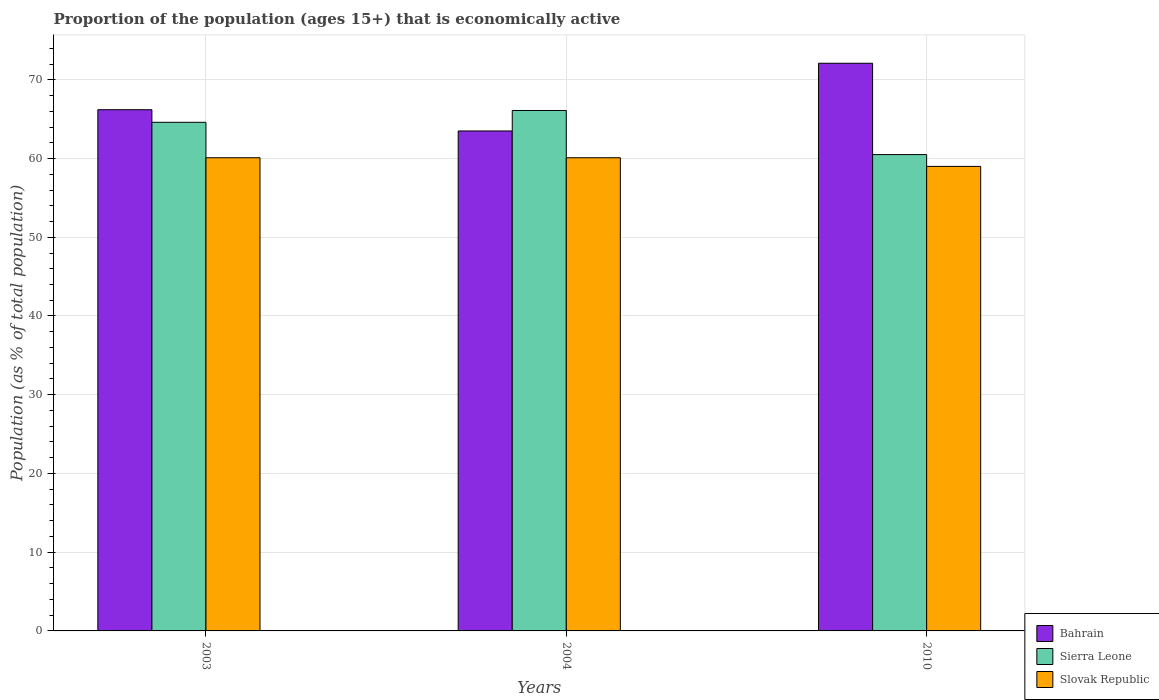How many different coloured bars are there?
Make the answer very short. 3. How many groups of bars are there?
Provide a succinct answer. 3. How many bars are there on the 3rd tick from the left?
Offer a terse response. 3. What is the proportion of the population that is economically active in Sierra Leone in 2004?
Your response must be concise. 66.1. Across all years, what is the maximum proportion of the population that is economically active in Sierra Leone?
Your answer should be very brief. 66.1. Across all years, what is the minimum proportion of the population that is economically active in Bahrain?
Provide a succinct answer. 63.5. In which year was the proportion of the population that is economically active in Bahrain minimum?
Offer a terse response. 2004. What is the total proportion of the population that is economically active in Slovak Republic in the graph?
Ensure brevity in your answer.  179.2. What is the difference between the proportion of the population that is economically active in Bahrain in 2003 and that in 2010?
Offer a very short reply. -5.9. What is the difference between the proportion of the population that is economically active in Bahrain in 2003 and the proportion of the population that is economically active in Sierra Leone in 2004?
Provide a short and direct response. 0.1. What is the average proportion of the population that is economically active in Sierra Leone per year?
Offer a very short reply. 63.73. In the year 2004, what is the difference between the proportion of the population that is economically active in Bahrain and proportion of the population that is economically active in Slovak Republic?
Provide a short and direct response. 3.4. In how many years, is the proportion of the population that is economically active in Sierra Leone greater than 2 %?
Your response must be concise. 3. What is the ratio of the proportion of the population that is economically active in Bahrain in 2003 to that in 2004?
Your answer should be very brief. 1.04. Is the proportion of the population that is economically active in Bahrain in 2003 less than that in 2004?
Make the answer very short. No. Is the difference between the proportion of the population that is economically active in Bahrain in 2003 and 2004 greater than the difference between the proportion of the population that is economically active in Slovak Republic in 2003 and 2004?
Your answer should be very brief. Yes. What is the difference between the highest and the lowest proportion of the population that is economically active in Sierra Leone?
Ensure brevity in your answer.  5.6. Is the sum of the proportion of the population that is economically active in Sierra Leone in 2003 and 2010 greater than the maximum proportion of the population that is economically active in Bahrain across all years?
Offer a terse response. Yes. What does the 2nd bar from the left in 2003 represents?
Provide a short and direct response. Sierra Leone. What does the 1st bar from the right in 2003 represents?
Keep it short and to the point. Slovak Republic. Where does the legend appear in the graph?
Your answer should be very brief. Bottom right. How many legend labels are there?
Your answer should be compact. 3. How are the legend labels stacked?
Your answer should be very brief. Vertical. What is the title of the graph?
Give a very brief answer. Proportion of the population (ages 15+) that is economically active. What is the label or title of the X-axis?
Your answer should be compact. Years. What is the label or title of the Y-axis?
Keep it short and to the point. Population (as % of total population). What is the Population (as % of total population) of Bahrain in 2003?
Your response must be concise. 66.2. What is the Population (as % of total population) of Sierra Leone in 2003?
Give a very brief answer. 64.6. What is the Population (as % of total population) in Slovak Republic in 2003?
Your answer should be very brief. 60.1. What is the Population (as % of total population) in Bahrain in 2004?
Your answer should be very brief. 63.5. What is the Population (as % of total population) in Sierra Leone in 2004?
Your answer should be very brief. 66.1. What is the Population (as % of total population) in Slovak Republic in 2004?
Make the answer very short. 60.1. What is the Population (as % of total population) of Bahrain in 2010?
Ensure brevity in your answer.  72.1. What is the Population (as % of total population) in Sierra Leone in 2010?
Make the answer very short. 60.5. Across all years, what is the maximum Population (as % of total population) in Bahrain?
Your answer should be very brief. 72.1. Across all years, what is the maximum Population (as % of total population) in Sierra Leone?
Your response must be concise. 66.1. Across all years, what is the maximum Population (as % of total population) of Slovak Republic?
Your answer should be very brief. 60.1. Across all years, what is the minimum Population (as % of total population) in Bahrain?
Your answer should be compact. 63.5. Across all years, what is the minimum Population (as % of total population) of Sierra Leone?
Make the answer very short. 60.5. What is the total Population (as % of total population) of Bahrain in the graph?
Provide a succinct answer. 201.8. What is the total Population (as % of total population) of Sierra Leone in the graph?
Give a very brief answer. 191.2. What is the total Population (as % of total population) of Slovak Republic in the graph?
Your response must be concise. 179.2. What is the difference between the Population (as % of total population) in Bahrain in 2003 and that in 2010?
Provide a short and direct response. -5.9. What is the difference between the Population (as % of total population) in Sierra Leone in 2003 and that in 2010?
Give a very brief answer. 4.1. What is the difference between the Population (as % of total population) of Slovak Republic in 2003 and that in 2010?
Provide a short and direct response. 1.1. What is the difference between the Population (as % of total population) in Sierra Leone in 2004 and that in 2010?
Provide a short and direct response. 5.6. What is the difference between the Population (as % of total population) of Slovak Republic in 2004 and that in 2010?
Provide a short and direct response. 1.1. What is the difference between the Population (as % of total population) of Bahrain in 2003 and the Population (as % of total population) of Slovak Republic in 2004?
Offer a very short reply. 6.1. What is the difference between the Population (as % of total population) of Sierra Leone in 2003 and the Population (as % of total population) of Slovak Republic in 2004?
Provide a short and direct response. 4.5. What is the difference between the Population (as % of total population) of Bahrain in 2003 and the Population (as % of total population) of Sierra Leone in 2010?
Offer a terse response. 5.7. What is the average Population (as % of total population) in Bahrain per year?
Your answer should be compact. 67.27. What is the average Population (as % of total population) of Sierra Leone per year?
Offer a very short reply. 63.73. What is the average Population (as % of total population) in Slovak Republic per year?
Your answer should be compact. 59.73. In the year 2003, what is the difference between the Population (as % of total population) in Bahrain and Population (as % of total population) in Sierra Leone?
Your answer should be very brief. 1.6. In the year 2004, what is the difference between the Population (as % of total population) in Sierra Leone and Population (as % of total population) in Slovak Republic?
Your response must be concise. 6. In the year 2010, what is the difference between the Population (as % of total population) in Bahrain and Population (as % of total population) in Sierra Leone?
Your answer should be very brief. 11.6. In the year 2010, what is the difference between the Population (as % of total population) in Bahrain and Population (as % of total population) in Slovak Republic?
Your response must be concise. 13.1. In the year 2010, what is the difference between the Population (as % of total population) in Sierra Leone and Population (as % of total population) in Slovak Republic?
Your response must be concise. 1.5. What is the ratio of the Population (as % of total population) of Bahrain in 2003 to that in 2004?
Make the answer very short. 1.04. What is the ratio of the Population (as % of total population) in Sierra Leone in 2003 to that in 2004?
Your answer should be very brief. 0.98. What is the ratio of the Population (as % of total population) of Slovak Republic in 2003 to that in 2004?
Offer a terse response. 1. What is the ratio of the Population (as % of total population) in Bahrain in 2003 to that in 2010?
Ensure brevity in your answer.  0.92. What is the ratio of the Population (as % of total population) in Sierra Leone in 2003 to that in 2010?
Your answer should be compact. 1.07. What is the ratio of the Population (as % of total population) in Slovak Republic in 2003 to that in 2010?
Provide a succinct answer. 1.02. What is the ratio of the Population (as % of total population) in Bahrain in 2004 to that in 2010?
Ensure brevity in your answer.  0.88. What is the ratio of the Population (as % of total population) of Sierra Leone in 2004 to that in 2010?
Offer a terse response. 1.09. What is the ratio of the Population (as % of total population) of Slovak Republic in 2004 to that in 2010?
Your answer should be very brief. 1.02. What is the difference between the highest and the second highest Population (as % of total population) in Bahrain?
Offer a very short reply. 5.9. What is the difference between the highest and the second highest Population (as % of total population) of Sierra Leone?
Keep it short and to the point. 1.5. What is the difference between the highest and the second highest Population (as % of total population) of Slovak Republic?
Your answer should be very brief. 0. What is the difference between the highest and the lowest Population (as % of total population) of Bahrain?
Provide a short and direct response. 8.6. 